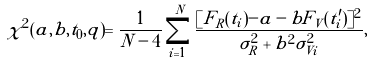<formula> <loc_0><loc_0><loc_500><loc_500>\chi ^ { 2 } ( a , b , t _ { 0 } , q ) = \frac { 1 } { N - 4 } \sum _ { i = 1 } ^ { N } \frac { [ F _ { R } ( t _ { i } ) - a - b F _ { V } ( t ^ { \prime } _ { i } ) ] ^ { 2 } } { \sigma _ { R } ^ { 2 } + b ^ { 2 } \sigma _ { V i } ^ { 2 } } ,</formula> 